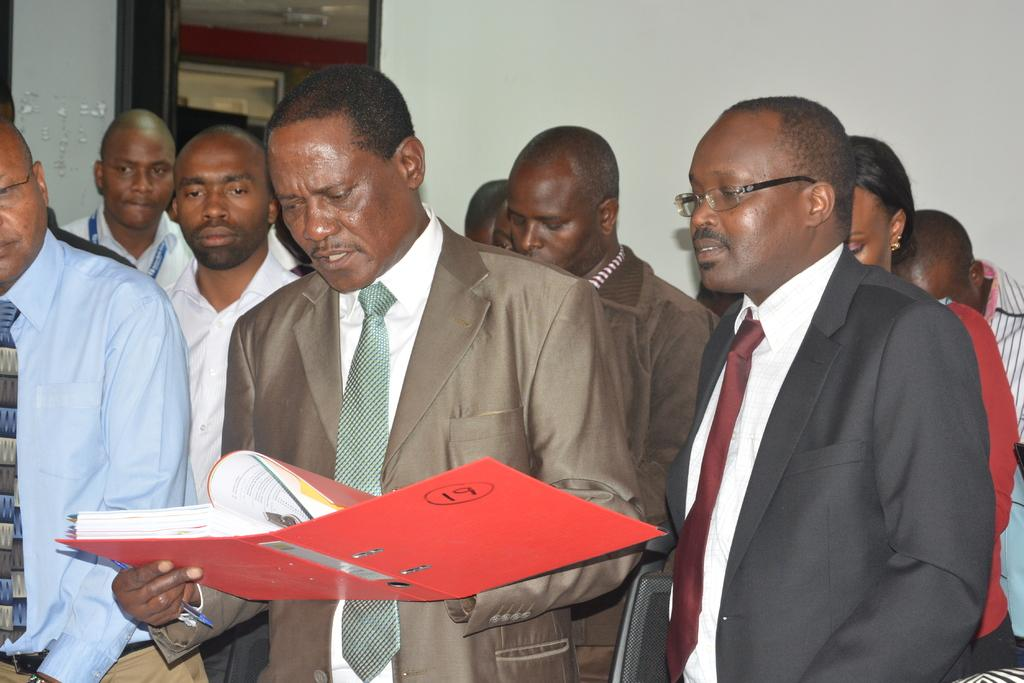How many people are in the image? There are few persons in the image. What is the man in the front of the image doing? The man is holding a book and reading in the front of the image. What can be seen in the background of the image? There is a wall in the background of the image. Is there any opening in the wall visible in the image? Yes, there is a window associated with the wall in the background of the image. What type of pest can be seen crawling on the man's shoulder in the image? There is no pest visible on the man's shoulder in the image. 